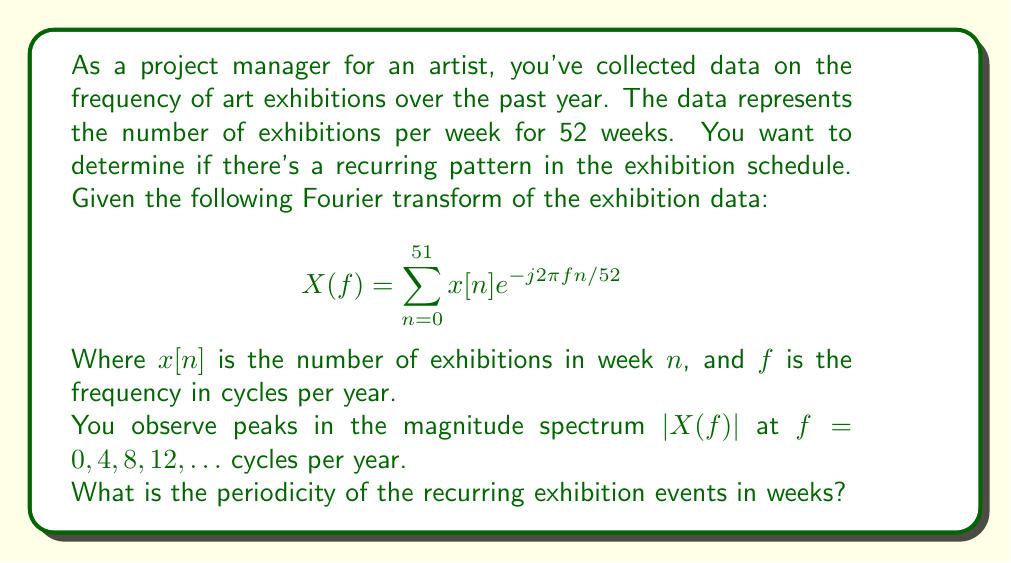Solve this math problem. To solve this problem, we'll follow these steps:

1) The Fourier transform $X(f)$ gives us information about the frequency components in the signal. The peaks in the magnitude spectrum $|X(f)|$ indicate the dominant frequencies in the data.

2) We observe peaks at $f = 0, 4, 8, 12, \ldots$ cycles per year. The non-zero frequencies are multiples of 4 cycles per year.

3) The fundamental frequency (the lowest non-zero frequency) is 4 cycles per year.

4) To find the periodicity in weeks, we need to convert from cycles per year to weeks:

   $$\text{Period} = \frac{1}{\text{Frequency}}$$

   $$\text{Period (in years)} = \frac{1}{4 \text{ cycles/year}} = \frac{1}{4} \text{ year}$$

5) To convert from years to weeks:

   $$\text{Period (in weeks)} = \frac{1}{4} \text{ year} \times 52 \text{ weeks/year} = 13 \text{ weeks}$$

Therefore, the recurring pattern in the exhibition schedule repeats every 13 weeks.
Answer: 13 weeks 